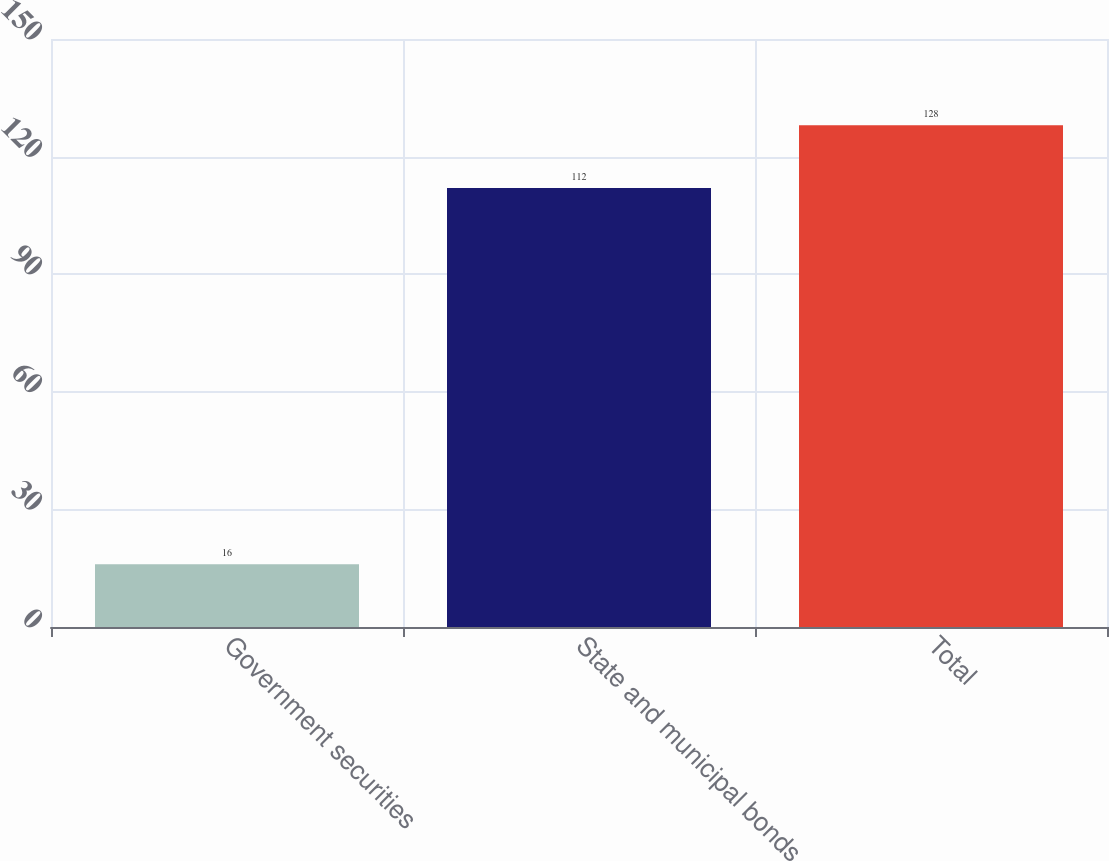<chart> <loc_0><loc_0><loc_500><loc_500><bar_chart><fcel>Government securities<fcel>State and municipal bonds<fcel>Total<nl><fcel>16<fcel>112<fcel>128<nl></chart> 